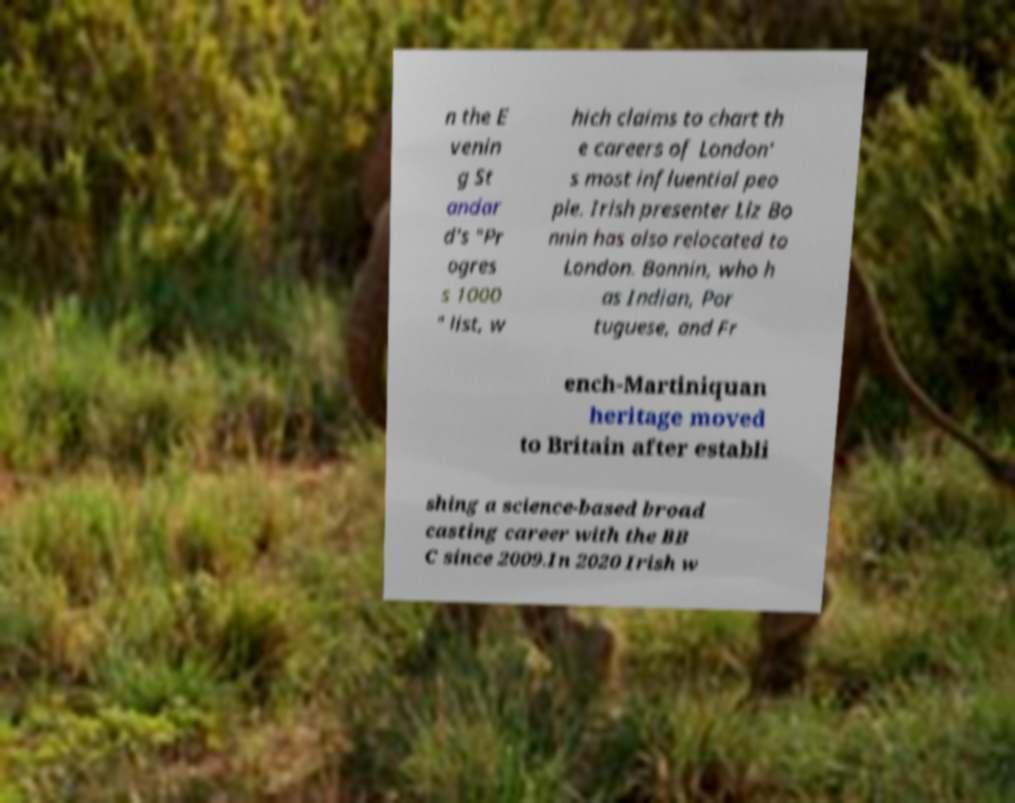Can you read and provide the text displayed in the image?This photo seems to have some interesting text. Can you extract and type it out for me? n the E venin g St andar d's "Pr ogres s 1000 " list, w hich claims to chart th e careers of London' s most influential peo ple. Irish presenter Liz Bo nnin has also relocated to London. Bonnin, who h as Indian, Por tuguese, and Fr ench-Martiniquan heritage moved to Britain after establi shing a science-based broad casting career with the BB C since 2009.In 2020 Irish w 